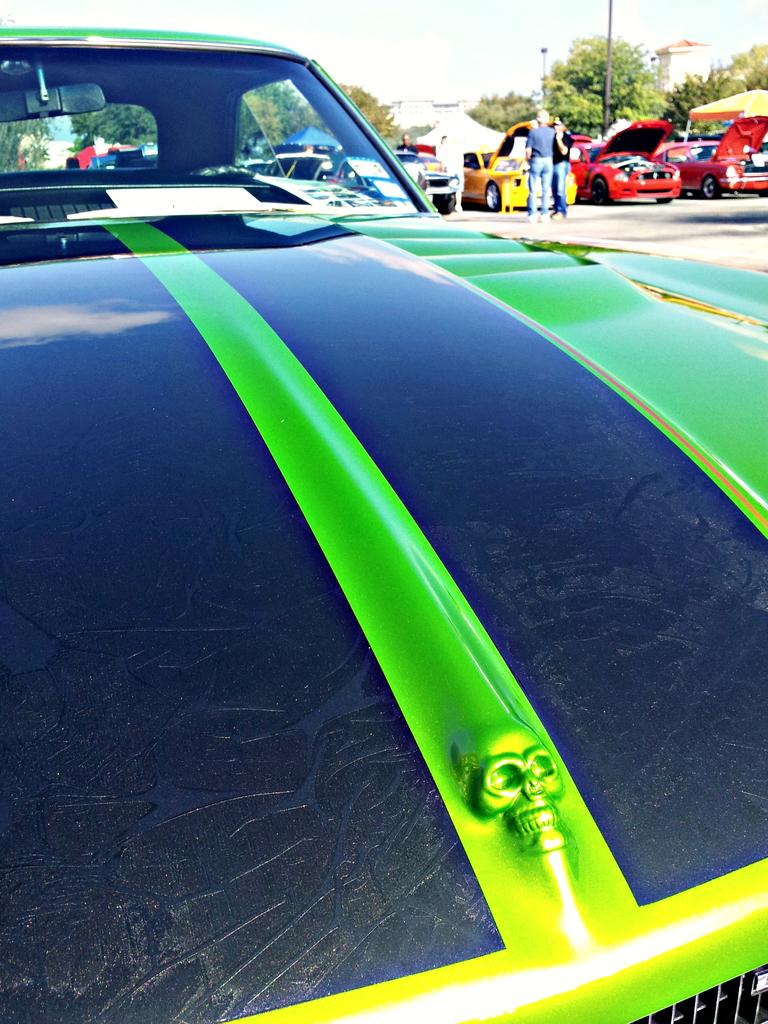What type of vehicles can be seen in the image? There are cars in the image. What type of shelter is present in the image? There is a tent in the image. Can you describe the people in the image? There is a group of people in the image. What type of vegetation is present in the image? There are trees in the image. What type of structure is present in the image? There is a building in the image. What is visible at the top of the image? The sky is visible at the top of the image. What type of furniture is being used for the feast in the image? There is no feast present in the image, and therefore no furniture for it. Can you describe the hose used for watering the plants in the image? There is no hose present in the image; it only features cars, a tent, a group of people, trees, a building, and the sky. 